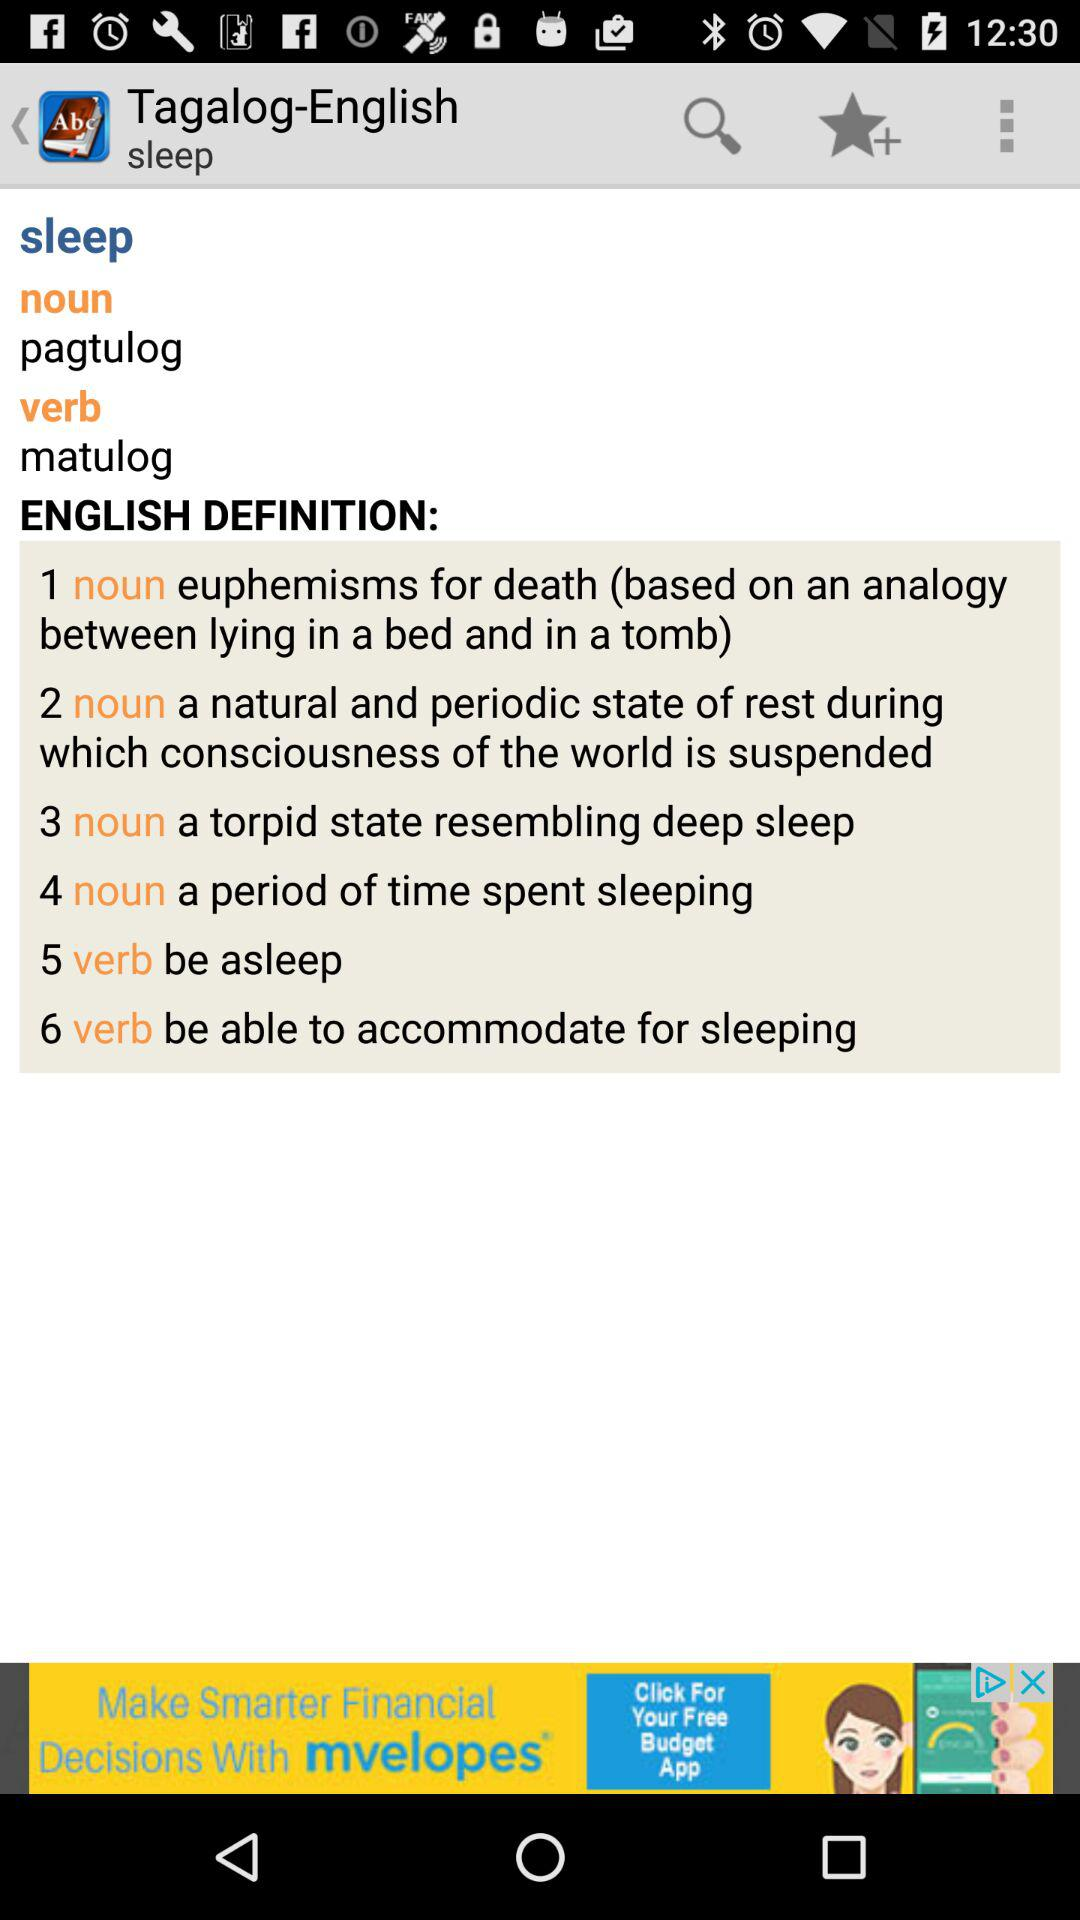How many more noun definitions are there than verb definitions?
Answer the question using a single word or phrase. 2 